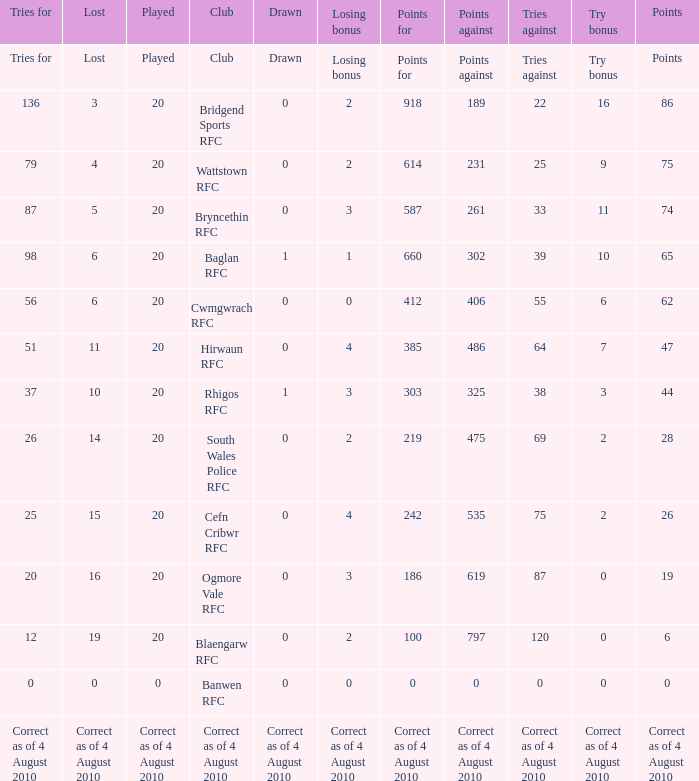What is the points against when the losing bonus is 0 and the club is banwen rfc? 0.0. 